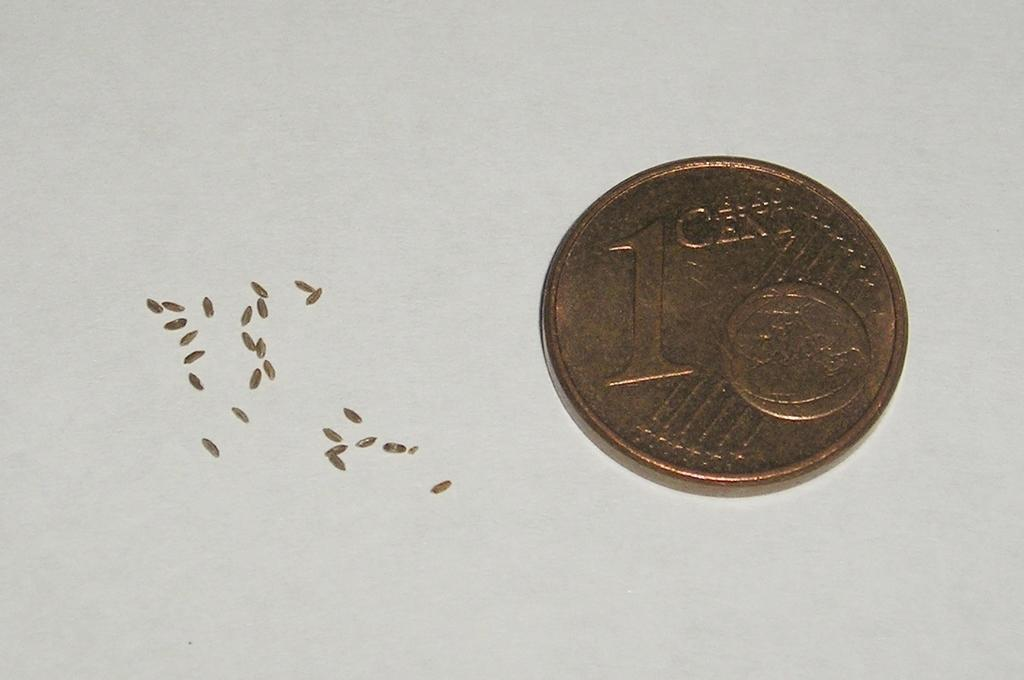<image>
Offer a succinct explanation of the picture presented. Tiny pieces of what appears to be grain lay next to a 1 cent piece. 